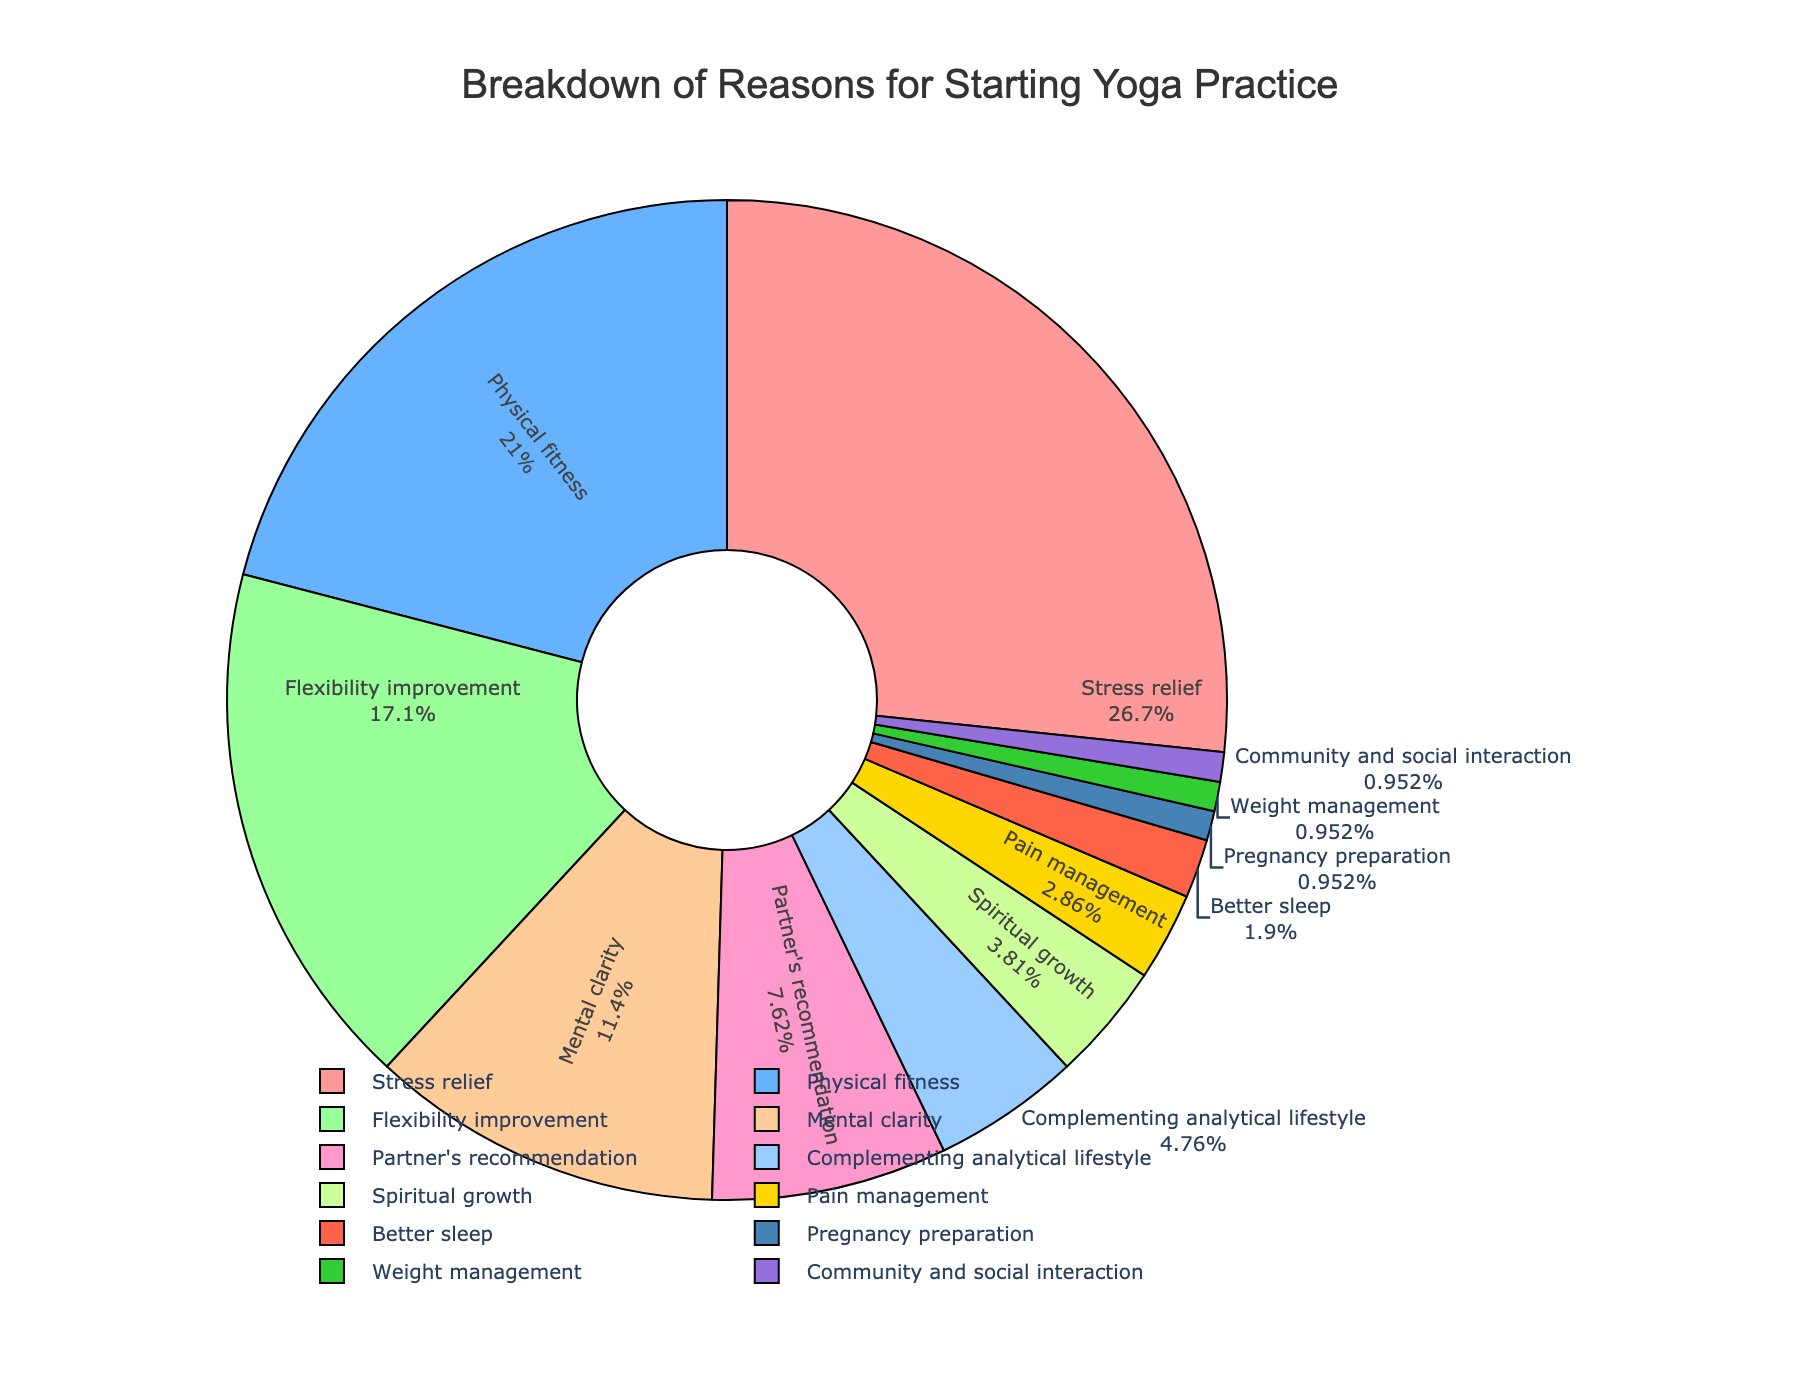Which reason is the most popular for starting yoga practice? Find the slice with the largest percentage value. The largest percentage value is 28%, which corresponds to "Stress relief".
Answer: Stress relief Which reason has the smallest percentage for starting yoga practice? Locate the slice with the smallest percentage value. The smallest percentage value is 1%, which corresponds to "Pregnancy preparation," "Weight management," and "Community and social interaction".
Answer: Pregnancy preparation, Weight management, Community and social interaction How much more popular is stress relief compared to flexibility improvement? Look at the percentages for "Stress relief" (28%) and "Flexibility improvement" (18%). Calculate the difference: 28% - 18% = 10%.
Answer: 10% What percent of people start yoga for reasons other than stress relief, physical fitness, and flexibility improvement combined? Add the percentages of "Stress relief" (28%), "Physical fitness" (22%), and "Flexibility improvement" (18%). Subtract this sum from 100%: 100% - (28% + 22% + 18%) = 32%.
Answer: 32% Which reasons are visually represented by more than one-fifth of the chart? Identify slices that represent more than 20%. Only the slices for "Stress relief" (28%) and "Physical fitness" (22%) fit this criterion.
Answer: Stress relief, Physical fitness Combine the percentages for partner's recommendation and complementing analytical lifestyle. What is the resulting percentage? Add the percentages for "Partner's recommendation" (8%) and "Complementing analytical lifestyle" (5%): 8% + 5% = 13%.
Answer: 13% What percentage of people practice yoga for physical fitness and mental clarity combined? Add the percentages for "Physical fitness" (22%) and "Mental clarity" (12%): 22% + 12% = 34%.
Answer: 34% Which reasons have a percentage lower than 5%? Identify the slices with percentages less than 5%. These include "Spiritual growth" (4%), "Pain management" (3%), "Better sleep" (2%), "Pregnancy preparation," "Weight management," and "Community and social interaction" (all at 1%).
Answer: Spiritual growth, Pain management, Better sleep, Pregnancy preparation, Weight management, Community and social interaction Which slice of the pie chart is depicted in yellow? Observe the chart to find the yellow slice. It corresponds to "Partner's recommendation".
Answer: Partner's recommendation What fraction of the pie chart does mental clarity represent? Look at the percentage for "Mental clarity," which is 12%. Express this as a fraction of 100: 12/100 = 3/25.
Answer: 3/25 